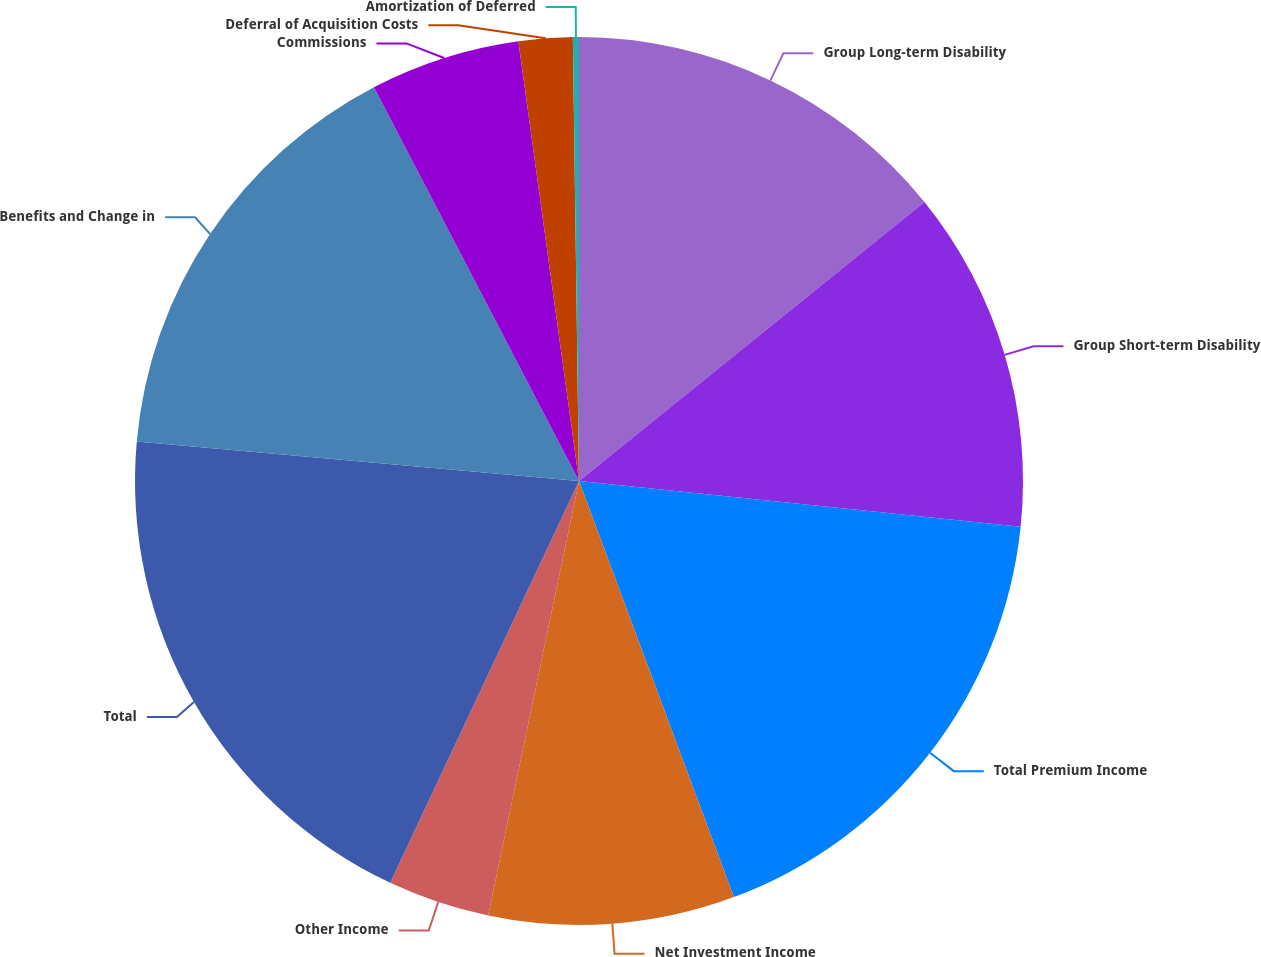Convert chart. <chart><loc_0><loc_0><loc_500><loc_500><pie_chart><fcel>Group Long-term Disability<fcel>Group Short-term Disability<fcel>Total Premium Income<fcel>Net Investment Income<fcel>Other Income<fcel>Total<fcel>Benefits and Change in<fcel>Commissions<fcel>Deferral of Acquisition Costs<fcel>Amortization of Deferred<nl><fcel>14.19%<fcel>12.45%<fcel>17.69%<fcel>8.95%<fcel>3.71%<fcel>19.43%<fcel>15.94%<fcel>5.46%<fcel>1.96%<fcel>0.22%<nl></chart> 